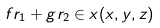<formula> <loc_0><loc_0><loc_500><loc_500>f r _ { 1 } + g r _ { 2 } \in x ( x , y , z )</formula> 